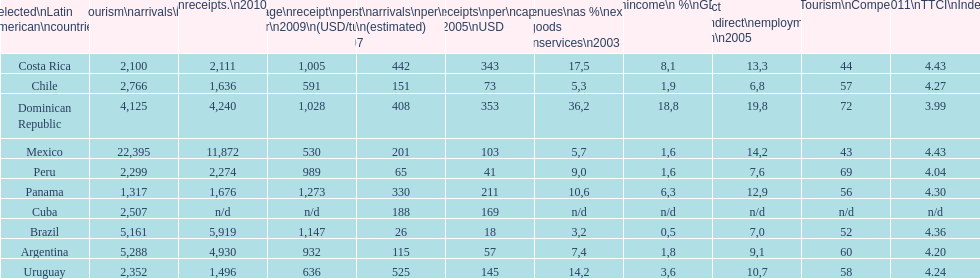Which latin american country had the largest number of tourism arrivals in 2010? Mexico. 